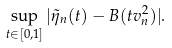<formula> <loc_0><loc_0><loc_500><loc_500>\sup _ { t \in [ 0 , 1 ] } | \tilde { \eta } _ { n } ( t ) - B ( t v _ { n } ^ { 2 } ) | .</formula> 